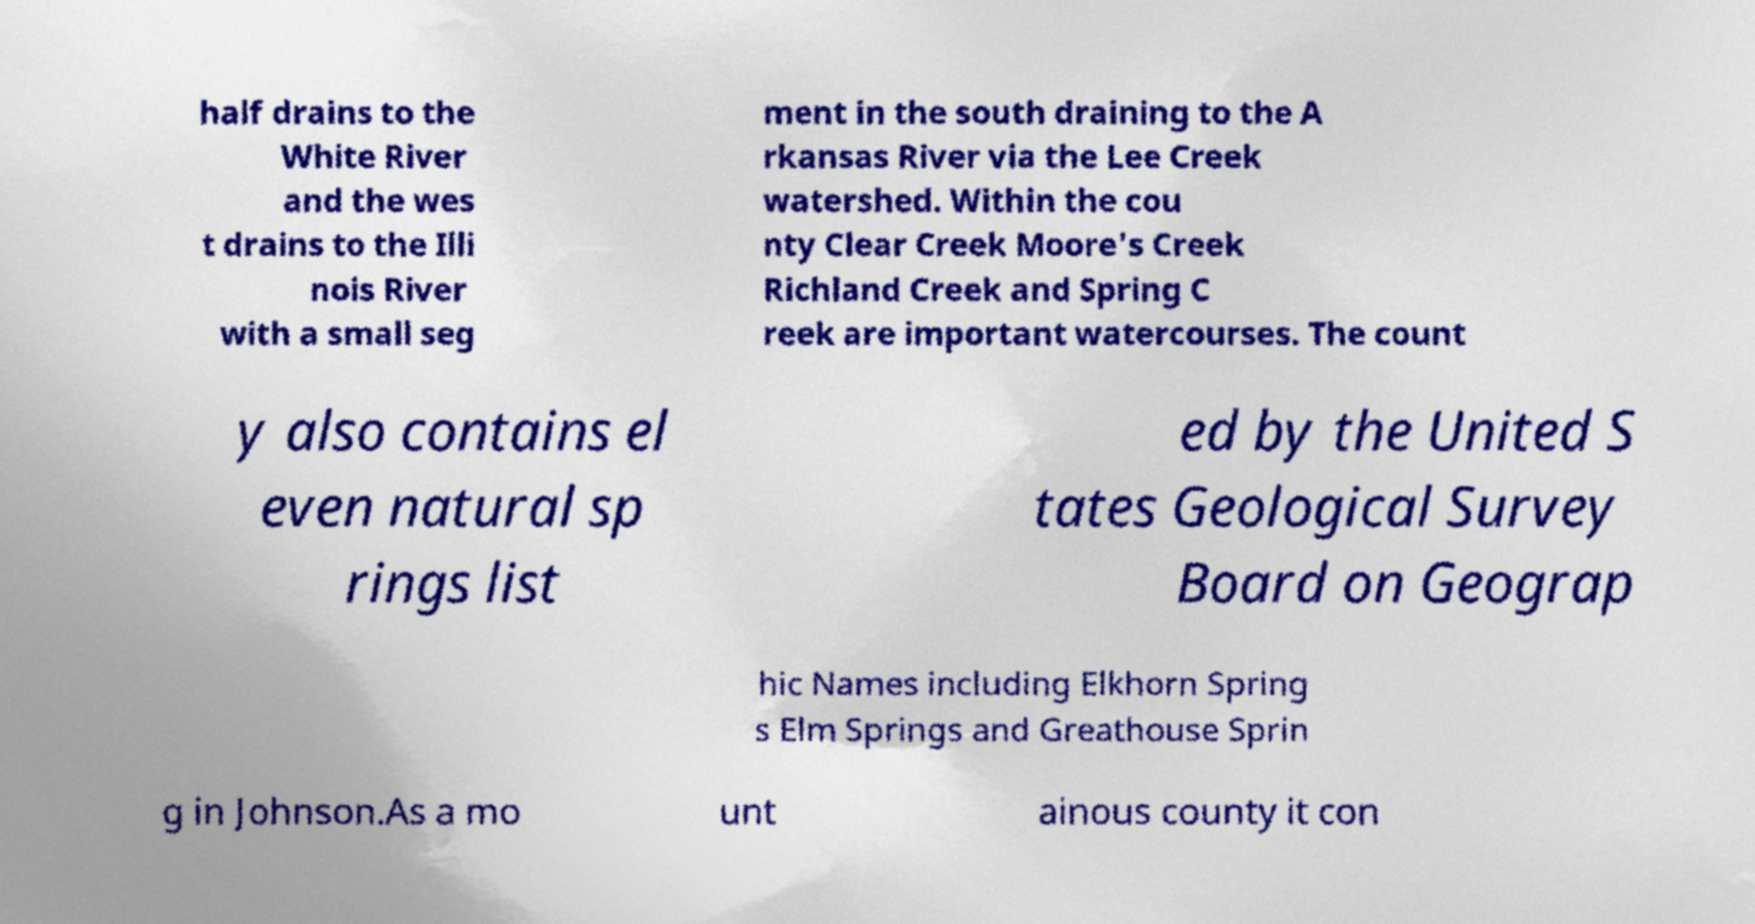What messages or text are displayed in this image? I need them in a readable, typed format. half drains to the White River and the wes t drains to the Illi nois River with a small seg ment in the south draining to the A rkansas River via the Lee Creek watershed. Within the cou nty Clear Creek Moore's Creek Richland Creek and Spring C reek are important watercourses. The count y also contains el even natural sp rings list ed by the United S tates Geological Survey Board on Geograp hic Names including Elkhorn Spring s Elm Springs and Greathouse Sprin g in Johnson.As a mo unt ainous county it con 